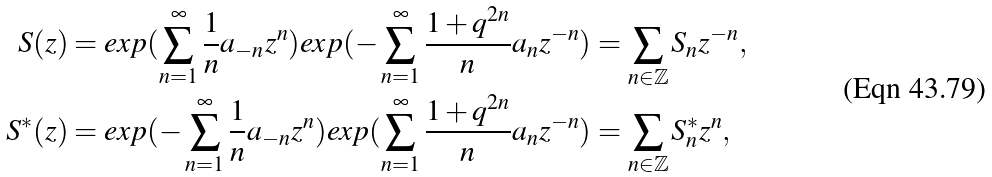Convert formula to latex. <formula><loc_0><loc_0><loc_500><loc_500>S ( z ) & = e x p ( \sum _ { n = 1 } ^ { \infty } \frac { 1 } { n } a _ { - n } z ^ { n } ) e x p ( - \sum _ { n = 1 } ^ { \infty } \frac { 1 + q ^ { 2 n } } { n } a _ { n } z ^ { - n } ) = \sum _ { n \in { \mathbb { Z } } } S _ { n } z ^ { - n } , \\ S ^ { * } ( z ) & = e x p ( - \sum _ { n = 1 } ^ { \infty } \frac { 1 } { n } a _ { - n } z ^ { n } ) e x p ( \sum _ { n = 1 } ^ { \infty } \frac { 1 + q ^ { 2 n } } { n } a _ { n } z ^ { - n } ) = \sum _ { n \in { \mathbb { Z } } } S _ { n } ^ { * } z ^ { n } ,</formula> 